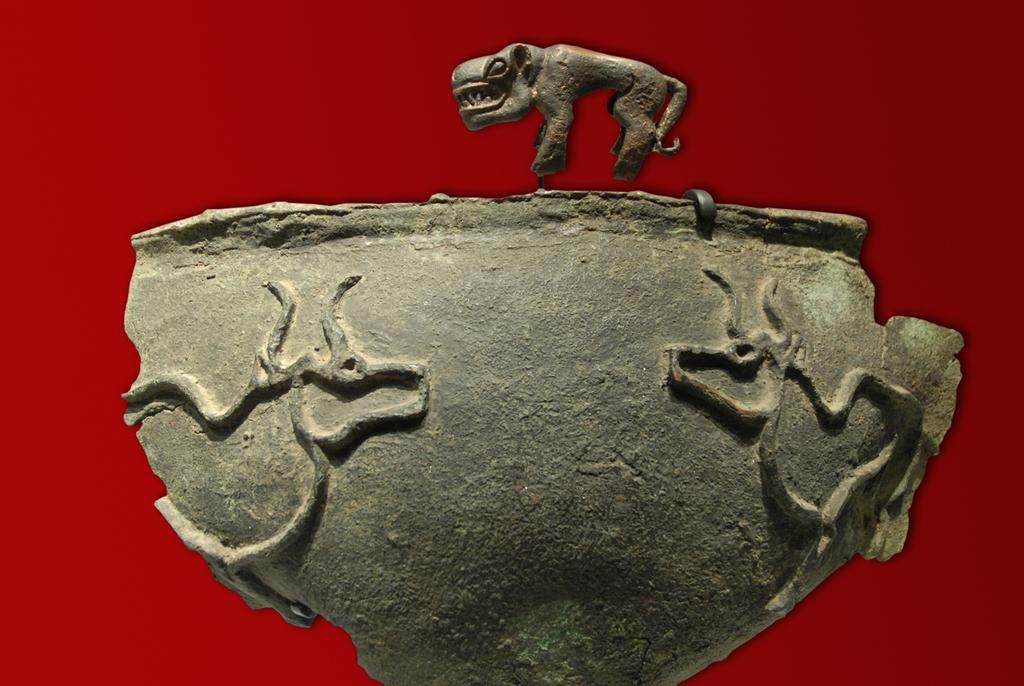What is the main subject of the image? There is a sculpture in the image. How many hens are interacting with the sculpture in the image? There are no hens present in the image; it only features a sculpture. 